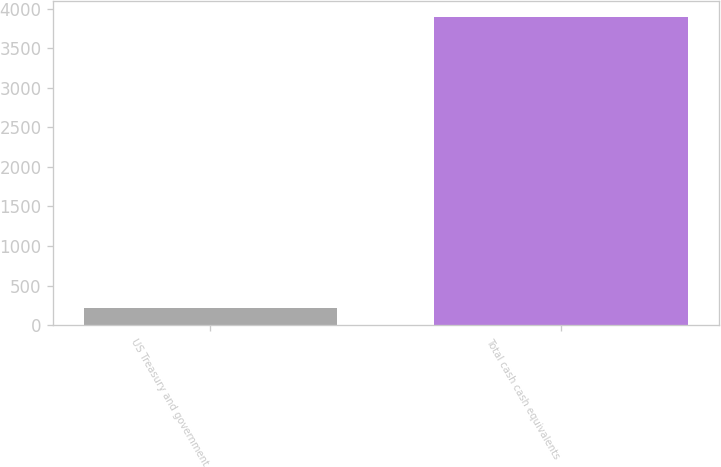<chart> <loc_0><loc_0><loc_500><loc_500><bar_chart><fcel>US Treasury and government<fcel>Total cash cash equivalents<nl><fcel>213<fcel>3899<nl></chart> 